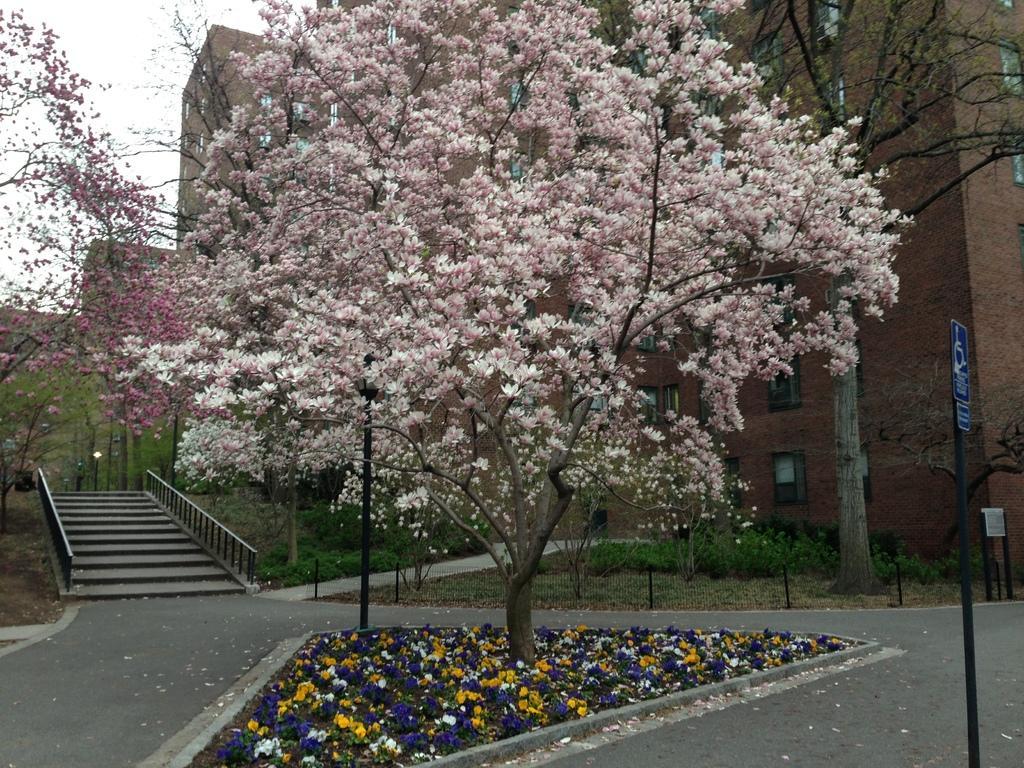Please provide a concise description of this image. In this image there are trees and we can see blossoms. In the background there are buildings and we can see boards. In the background there is sky. On the left there are stairs. 